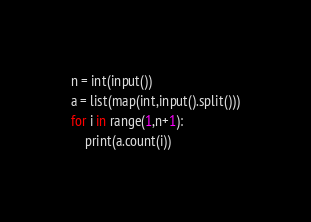Convert code to text. <code><loc_0><loc_0><loc_500><loc_500><_Python_>n = int(input())
a = list(map(int,input().split()))
for i in range(1,n+1):
    print(a.count(i))</code> 